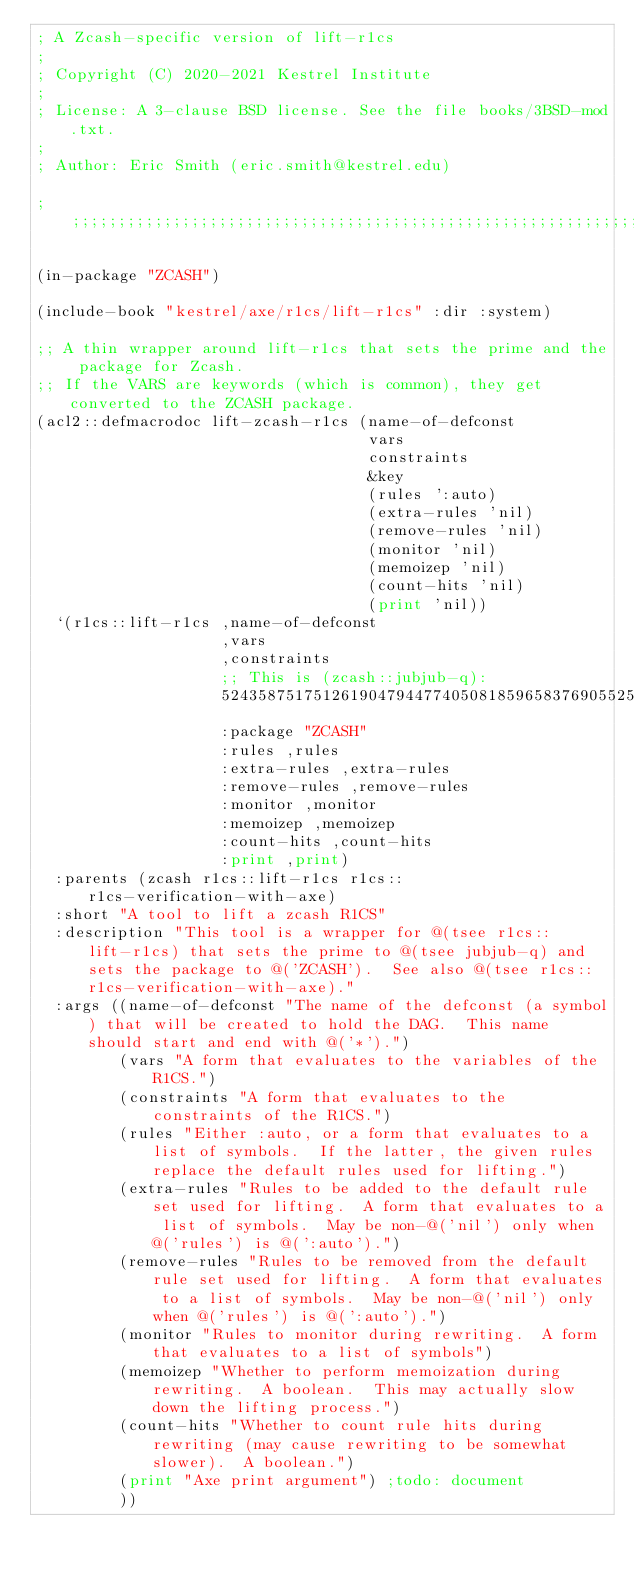<code> <loc_0><loc_0><loc_500><loc_500><_Lisp_>; A Zcash-specific version of lift-r1cs
;
; Copyright (C) 2020-2021 Kestrel Institute
;
; License: A 3-clause BSD license. See the file books/3BSD-mod.txt.
;
; Author: Eric Smith (eric.smith@kestrel.edu)

;;;;;;;;;;;;;;;;;;;;;;;;;;;;;;;;;;;;;;;;;;;;;;;;;;;;;;;;;;;;;;;;;;;;;;;;;;;;;;;;

(in-package "ZCASH")

(include-book "kestrel/axe/r1cs/lift-r1cs" :dir :system)

;; A thin wrapper around lift-r1cs that sets the prime and the package for Zcash.
;; If the VARS are keywords (which is common), they get converted to the ZCASH package.
(acl2::defmacrodoc lift-zcash-r1cs (name-of-defconst
                                    vars
                                    constraints
                                    &key
                                    (rules ':auto)
                                    (extra-rules 'nil)
                                    (remove-rules 'nil)
                                    (monitor 'nil)
                                    (memoizep 'nil)
                                    (count-hits 'nil)
                                    (print 'nil))
  `(r1cs::lift-r1cs ,name-of-defconst
                    ,vars
                    ,constraints
                    ;; This is (zcash::jubjub-q):
                    52435875175126190479447740508185965837690552500527637822603658699938581184513
                    :package "ZCASH"
                    :rules ,rules
                    :extra-rules ,extra-rules
                    :remove-rules ,remove-rules
                    :monitor ,monitor
                    :memoizep ,memoizep
                    :count-hits ,count-hits
                    :print ,print)
  :parents (zcash r1cs::lift-r1cs r1cs::r1cs-verification-with-axe)
  :short "A tool to lift a zcash R1CS"
  :description "This tool is a wrapper for @(tsee r1cs::lift-r1cs) that sets the prime to @(tsee jubjub-q) and sets the package to @('ZCASH').  See also @(tsee r1cs::r1cs-verification-with-axe)."
  :args ((name-of-defconst "The name of the defconst (a symbol) that will be created to hold the DAG.  This name should start and end with @('*').")
         (vars "A form that evaluates to the variables of the R1CS.")
         (constraints "A form that evaluates to the constraints of the R1CS.")
         (rules "Either :auto, or a form that evaluates to a list of symbols.  If the latter, the given rules replace the default rules used for lifting.")
         (extra-rules "Rules to be added to the default rule set used for lifting.  A form that evaluates to a list of symbols.  May be non-@('nil') only when @('rules') is @(':auto').")
         (remove-rules "Rules to be removed from the default rule set used for lifting.  A form that evaluates to a list of symbols.  May be non-@('nil') only when @('rules') is @(':auto').")
         (monitor "Rules to monitor during rewriting.  A form that evaluates to a list of symbols")
         (memoizep "Whether to perform memoization during rewriting.  A boolean.  This may actually slow down the lifting process.")
         (count-hits "Whether to count rule hits during rewriting (may cause rewriting to be somewhat slower).  A boolean.")
         (print "Axe print argument") ;todo: document
         ))
</code> 